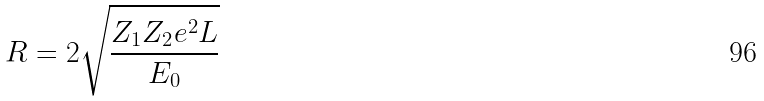Convert formula to latex. <formula><loc_0><loc_0><loc_500><loc_500>R = 2 \sqrt { \frac { Z _ { 1 } Z _ { 2 } e ^ { 2 } L } { E _ { 0 } } }</formula> 